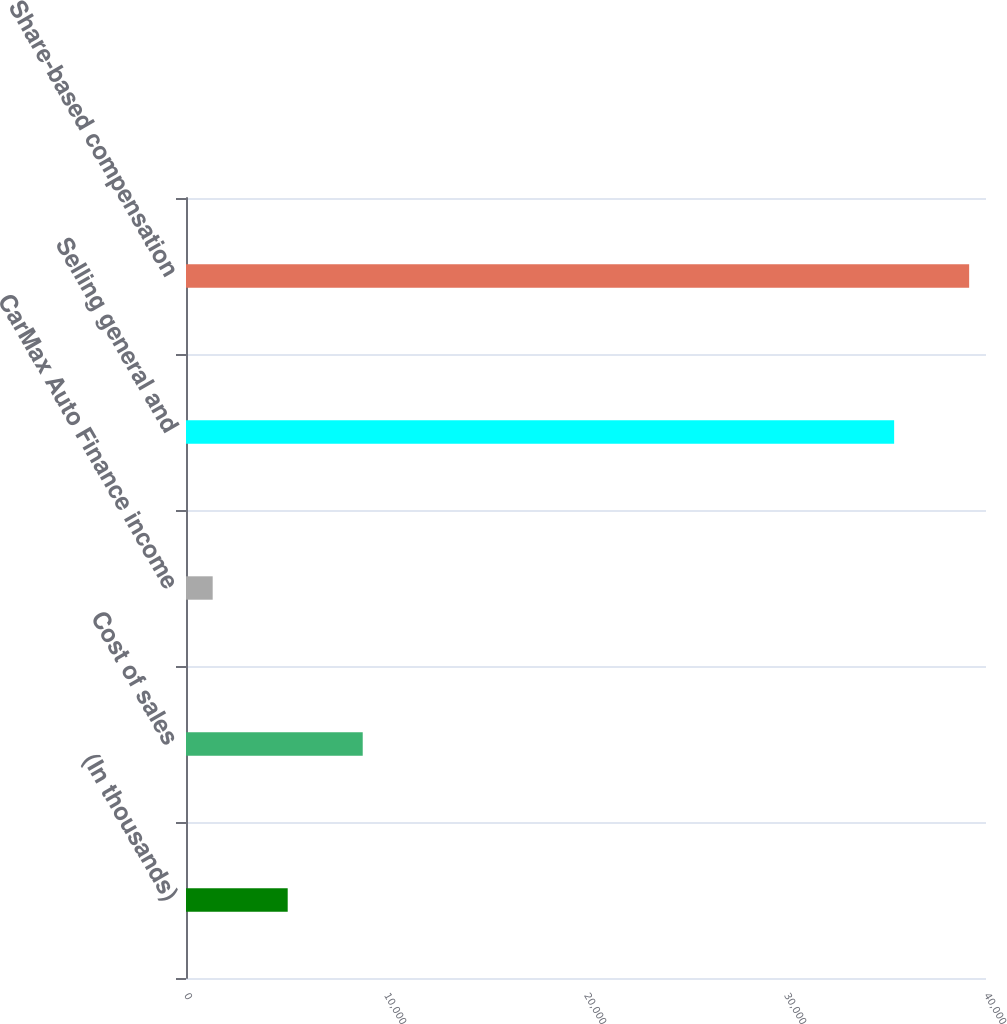Convert chart to OTSL. <chart><loc_0><loc_0><loc_500><loc_500><bar_chart><fcel>(In thousands)<fcel>Cost of sales<fcel>CarMax Auto Finance income<fcel>Selling general and<fcel>Share-based compensation<nl><fcel>5085<fcel>8836<fcel>1334<fcel>35407<fcel>39158<nl></chart> 